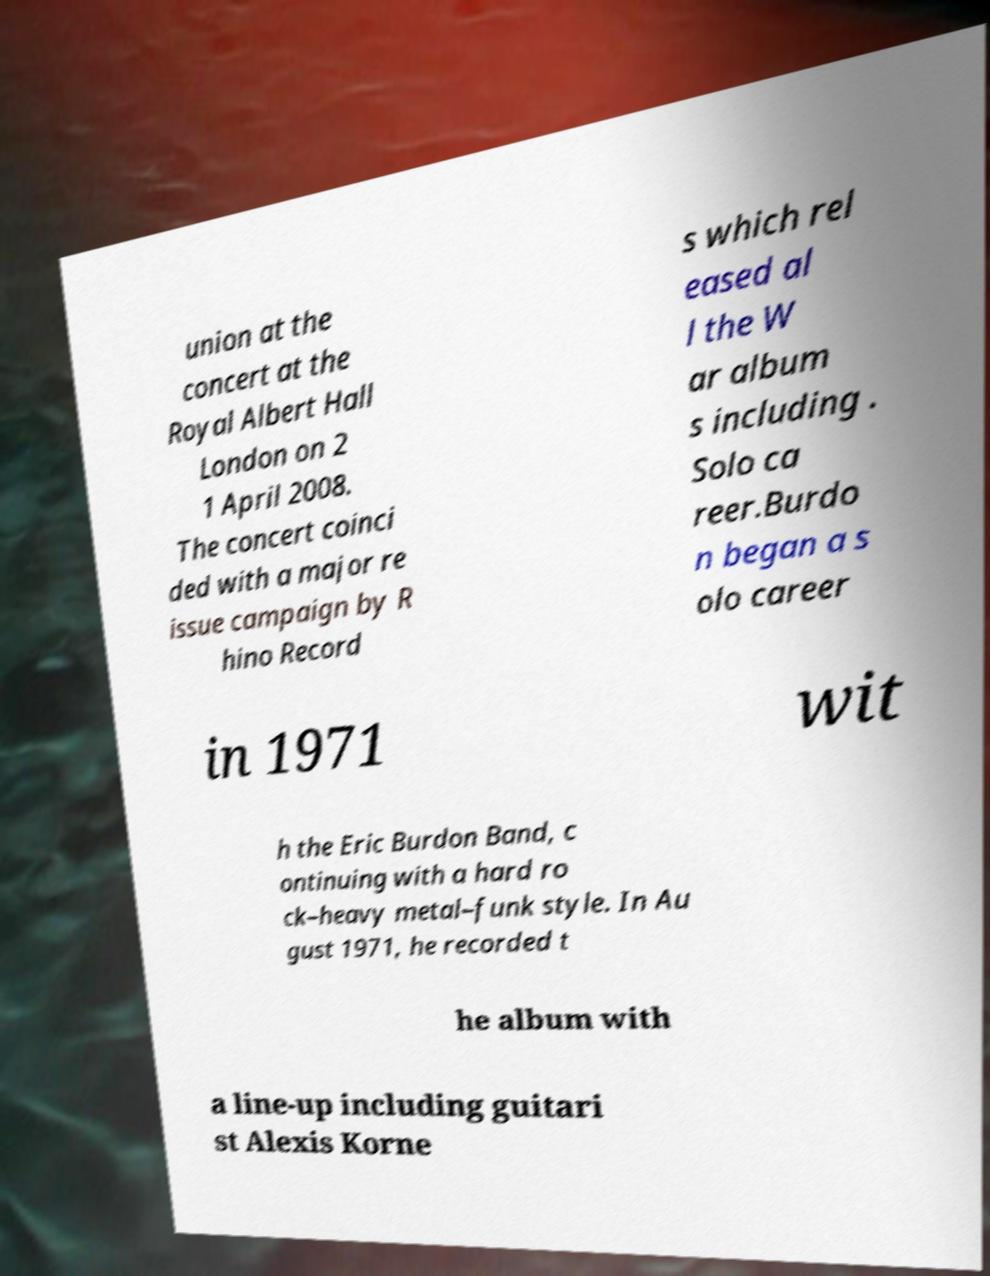Can you accurately transcribe the text from the provided image for me? union at the concert at the Royal Albert Hall London on 2 1 April 2008. The concert coinci ded with a major re issue campaign by R hino Record s which rel eased al l the W ar album s including . Solo ca reer.Burdo n began a s olo career in 1971 wit h the Eric Burdon Band, c ontinuing with a hard ro ck–heavy metal–funk style. In Au gust 1971, he recorded t he album with a line-up including guitari st Alexis Korne 